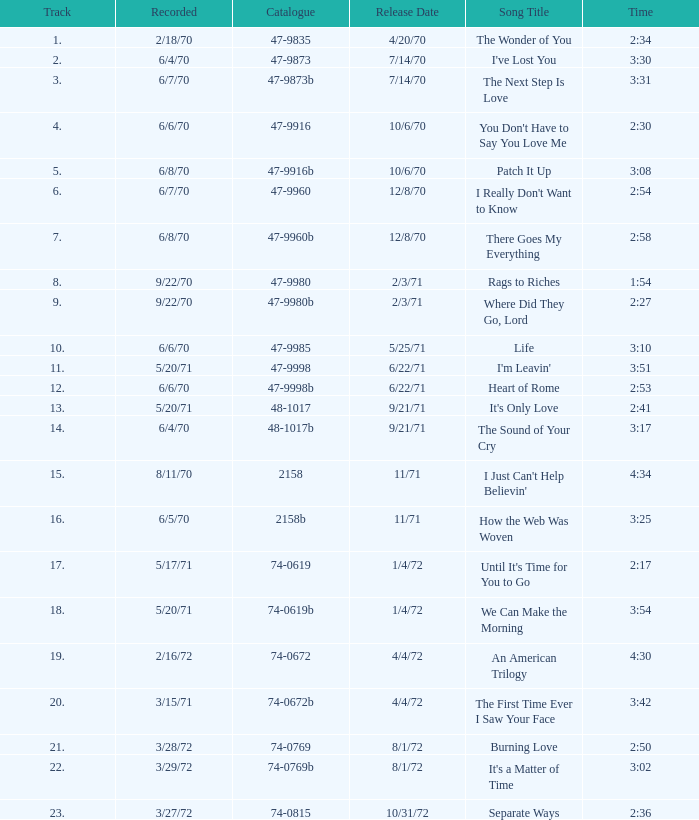What is the highest track for Burning Love? 21.0. Would you be able to parse every entry in this table? {'header': ['Track', 'Recorded', 'Catalogue', 'Release Date', 'Song Title', 'Time'], 'rows': [['1.', '2/18/70', '47-9835', '4/20/70', 'The Wonder of You', '2:34'], ['2.', '6/4/70', '47-9873', '7/14/70', "I've Lost You", '3:30'], ['3.', '6/7/70', '47-9873b', '7/14/70', 'The Next Step Is Love', '3:31'], ['4.', '6/6/70', '47-9916', '10/6/70', "You Don't Have to Say You Love Me", '2:30'], ['5.', '6/8/70', '47-9916b', '10/6/70', 'Patch It Up', '3:08'], ['6.', '6/7/70', '47-9960', '12/8/70', "I Really Don't Want to Know", '2:54'], ['7.', '6/8/70', '47-9960b', '12/8/70', 'There Goes My Everything', '2:58'], ['8.', '9/22/70', '47-9980', '2/3/71', 'Rags to Riches', '1:54'], ['9.', '9/22/70', '47-9980b', '2/3/71', 'Where Did They Go, Lord', '2:27'], ['10.', '6/6/70', '47-9985', '5/25/71', 'Life', '3:10'], ['11.', '5/20/71', '47-9998', '6/22/71', "I'm Leavin'", '3:51'], ['12.', '6/6/70', '47-9998b', '6/22/71', 'Heart of Rome', '2:53'], ['13.', '5/20/71', '48-1017', '9/21/71', "It's Only Love", '2:41'], ['14.', '6/4/70', '48-1017b', '9/21/71', 'The Sound of Your Cry', '3:17'], ['15.', '8/11/70', '2158', '11/71', "I Just Can't Help Believin'", '4:34'], ['16.', '6/5/70', '2158b', '11/71', 'How the Web Was Woven', '3:25'], ['17.', '5/17/71', '74-0619', '1/4/72', "Until It's Time for You to Go", '2:17'], ['18.', '5/20/71', '74-0619b', '1/4/72', 'We Can Make the Morning', '3:54'], ['19.', '2/16/72', '74-0672', '4/4/72', 'An American Trilogy', '4:30'], ['20.', '3/15/71', '74-0672b', '4/4/72', 'The First Time Ever I Saw Your Face', '3:42'], ['21.', '3/28/72', '74-0769', '8/1/72', 'Burning Love', '2:50'], ['22.', '3/29/72', '74-0769b', '8/1/72', "It's a Matter of Time", '3:02'], ['23.', '3/27/72', '74-0815', '10/31/72', 'Separate Ways', '2:36']]} 